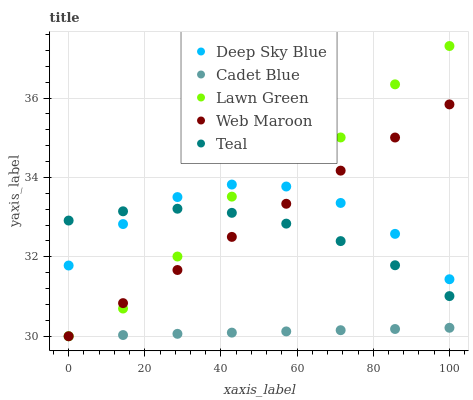Does Cadet Blue have the minimum area under the curve?
Answer yes or no. Yes. Does Lawn Green have the maximum area under the curve?
Answer yes or no. Yes. Does Web Maroon have the minimum area under the curve?
Answer yes or no. No. Does Web Maroon have the maximum area under the curve?
Answer yes or no. No. Is Cadet Blue the smoothest?
Answer yes or no. Yes. Is Lawn Green the roughest?
Answer yes or no. Yes. Is Web Maroon the smoothest?
Answer yes or no. No. Is Web Maroon the roughest?
Answer yes or no. No. Does Lawn Green have the lowest value?
Answer yes or no. Yes. Does Teal have the lowest value?
Answer yes or no. No. Does Lawn Green have the highest value?
Answer yes or no. Yes. Does Web Maroon have the highest value?
Answer yes or no. No. Is Cadet Blue less than Teal?
Answer yes or no. Yes. Is Deep Sky Blue greater than Cadet Blue?
Answer yes or no. Yes. Does Web Maroon intersect Lawn Green?
Answer yes or no. Yes. Is Web Maroon less than Lawn Green?
Answer yes or no. No. Is Web Maroon greater than Lawn Green?
Answer yes or no. No. Does Cadet Blue intersect Teal?
Answer yes or no. No. 